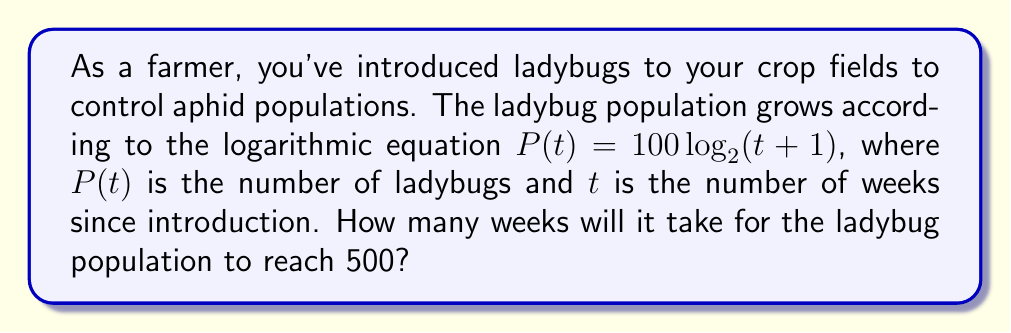Could you help me with this problem? Let's approach this step-by-step:

1) We're given the equation $P(t) = 100 \log_2(t+1)$

2) We want to find $t$ when $P(t) = 500$. So, let's set up the equation:

   $500 = 100 \log_2(t+1)$

3) Divide both sides by 100:

   $5 = \log_2(t+1)$

4) To solve for $t$, we need to apply the inverse function of $\log_2$, which is $2^x$:

   $2^5 = t+1$

5) Calculate $2^5$:

   $32 = t+1$

6) Subtract 1 from both sides:

   $31 = t$

7) Since $t$ represents weeks, and we can't have a fractional number of weeks in this context, we round up to the nearest whole number.

Therefore, it will take 31 weeks for the ladybug population to reach 500.
Answer: 31 weeks 